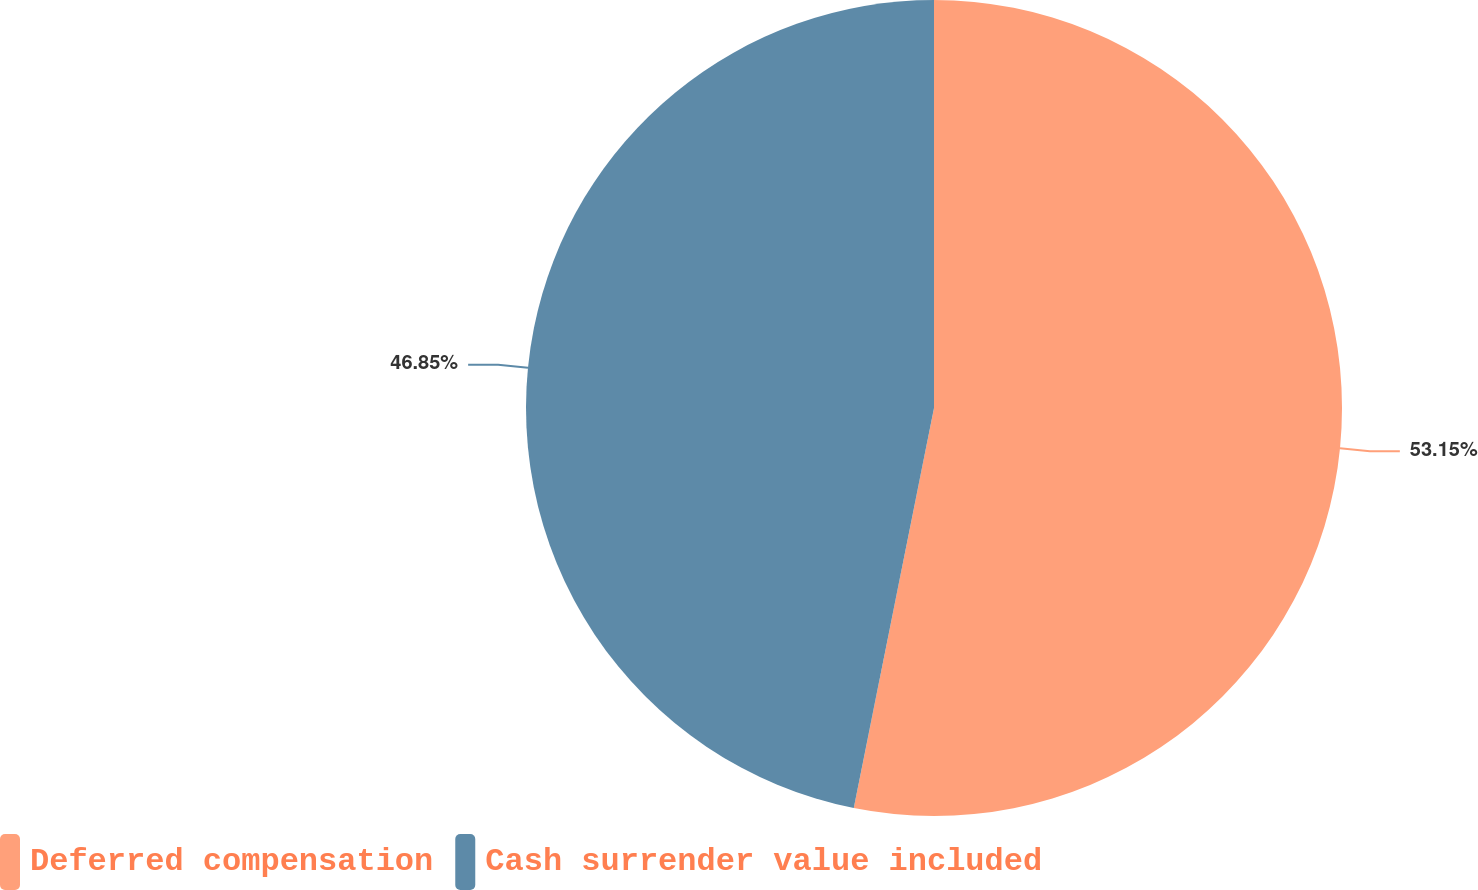<chart> <loc_0><loc_0><loc_500><loc_500><pie_chart><fcel>Deferred compensation<fcel>Cash surrender value included<nl><fcel>53.15%<fcel>46.85%<nl></chart> 